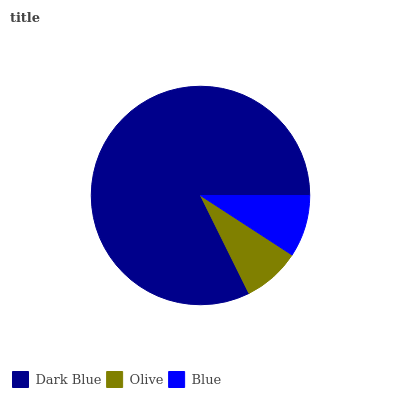Is Olive the minimum?
Answer yes or no. Yes. Is Dark Blue the maximum?
Answer yes or no. Yes. Is Blue the minimum?
Answer yes or no. No. Is Blue the maximum?
Answer yes or no. No. Is Blue greater than Olive?
Answer yes or no. Yes. Is Olive less than Blue?
Answer yes or no. Yes. Is Olive greater than Blue?
Answer yes or no. No. Is Blue less than Olive?
Answer yes or no. No. Is Blue the high median?
Answer yes or no. Yes. Is Blue the low median?
Answer yes or no. Yes. Is Dark Blue the high median?
Answer yes or no. No. Is Dark Blue the low median?
Answer yes or no. No. 